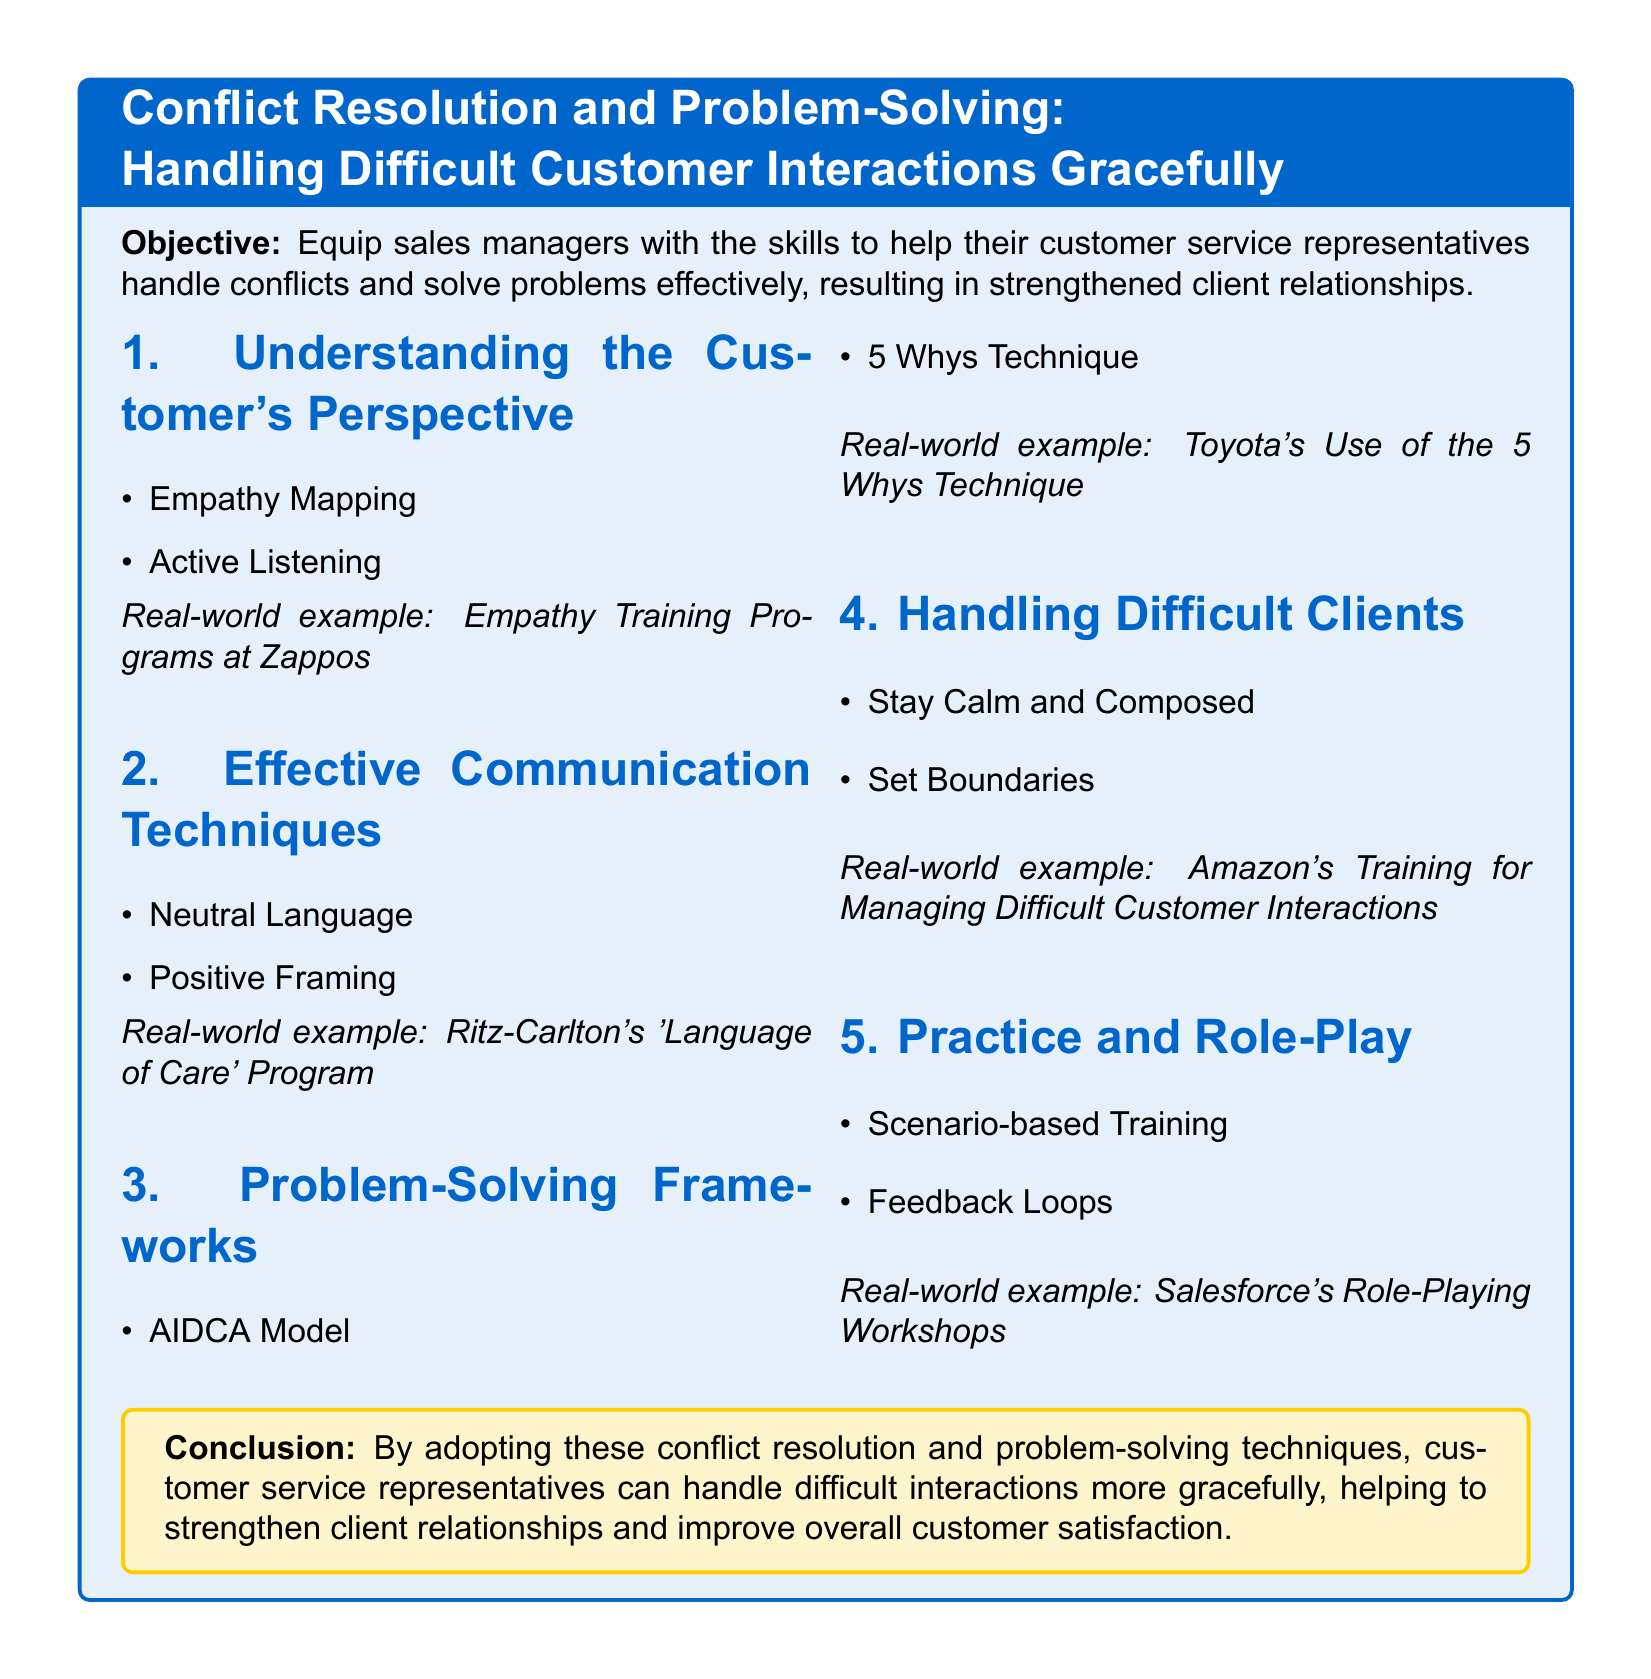what is the title of the lesson plan? The title of the lesson plan is presented at the beginning of the document within a colorful box.
Answer: Conflict Resolution and Problem-Solving: Handling Difficult Customer Interactions Gracefully what is the objective of the lesson plan? The objective is outlined in the colored box at the top of the document.
Answer: Equip sales managers with the skills to help their customer service representatives handle conflicts and solve problems effectively, resulting in strengthened client relationships name one technique listed under Effective Communication Techniques. The document lists techniques under each section, and one can be found under Effective Communication Techniques.
Answer: Neutral Language which real-world example is cited for the 5 Whys Technique? The real-world example is mentioned next to the Problem-Solving Frameworks section.
Answer: Toyota's Use of the 5 Whys Technique what is one way to handle difficult clients? The section on Handling Difficult Clients contains strategies for managing those interactions.
Answer: Stay Calm and Composed how many sections are included in the lesson plan? The lesson plan consists of multiple sections that focus on different areas of conflict resolution and problem-solving.
Answer: 5 what type of training does Salesforce offer as per the document? The document describes the training format used by Salesforce to prepare customer service representatives.
Answer: Role-Playing Workshops what is a key takeaway from the conclusion? The conclusion summarizes the overall aim of the lesson plan and its benefits.
Answer: Strengthen client relationships and improve overall customer satisfaction 